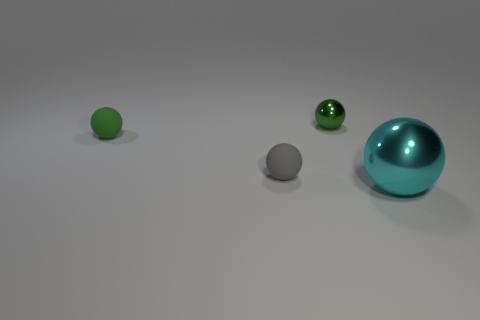Subtract all small metal spheres. How many spheres are left? 3 Add 1 big cyan objects. How many objects exist? 5 Subtract all green balls. How many balls are left? 2 Subtract all green metallic objects. Subtract all tiny objects. How many objects are left? 0 Add 1 matte things. How many matte things are left? 3 Add 3 big yellow objects. How many big yellow objects exist? 3 Subtract 0 blue cylinders. How many objects are left? 4 Subtract all green balls. Subtract all purple blocks. How many balls are left? 2 Subtract all purple cubes. How many gray spheres are left? 1 